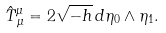Convert formula to latex. <formula><loc_0><loc_0><loc_500><loc_500>\hat { T } ^ { \mu } _ { \, \mu } = 2 \sqrt { - h } \, d \eta _ { 0 } \wedge \eta _ { 1 } .</formula> 